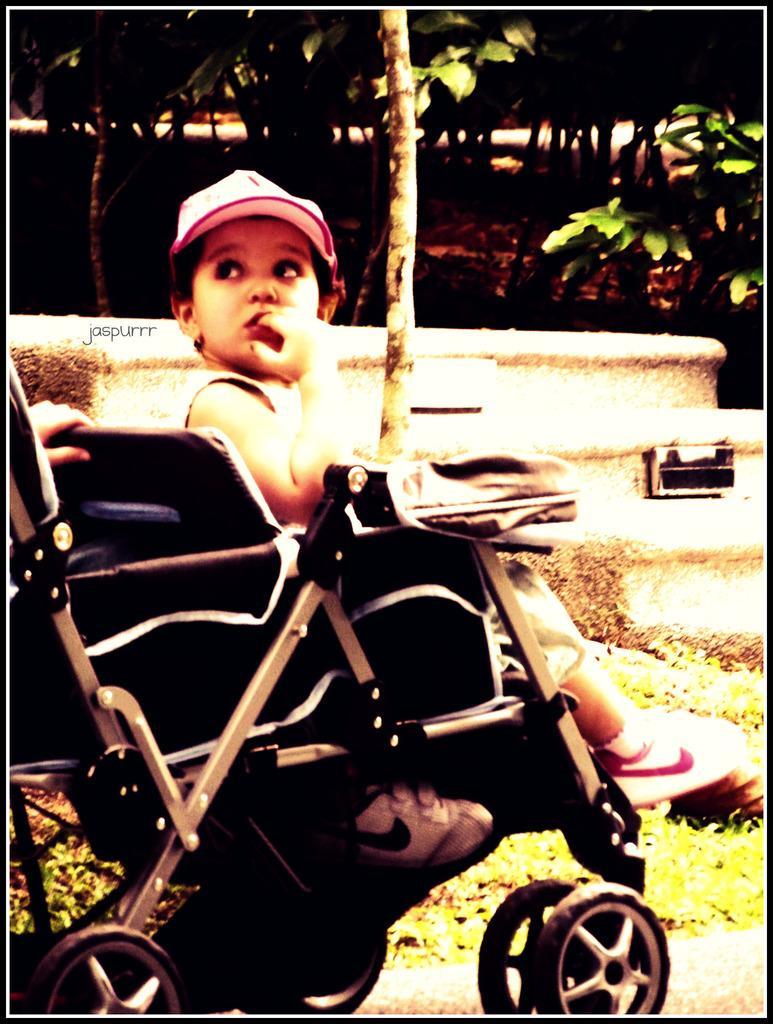Please provide a concise description of this image. There is one kid sitting in a baby stroller as we can see in the middle of this image. There are trees in the background. We can see a human hand on the left side of this image. 